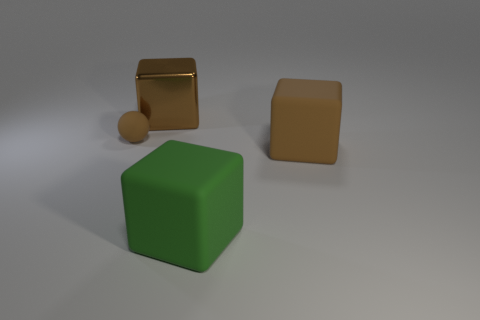Add 2 large things. How many objects exist? 6 Subtract all balls. How many objects are left? 3 Add 4 green blocks. How many green blocks are left? 5 Add 4 green cubes. How many green cubes exist? 5 Subtract 0 gray balls. How many objects are left? 4 Subtract all small red cylinders. Subtract all brown spheres. How many objects are left? 3 